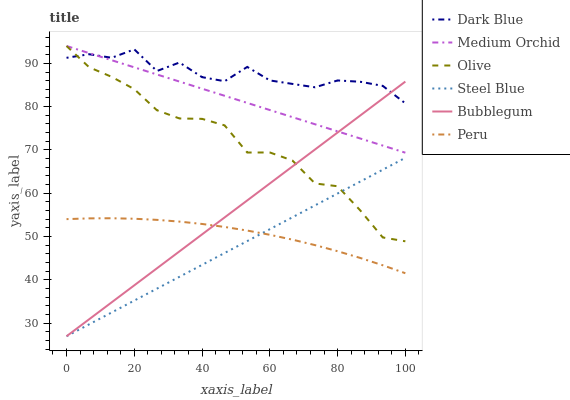Does Steel Blue have the minimum area under the curve?
Answer yes or no. Yes. Does Dark Blue have the maximum area under the curve?
Answer yes or no. Yes. Does Bubblegum have the minimum area under the curve?
Answer yes or no. No. Does Bubblegum have the maximum area under the curve?
Answer yes or no. No. Is Steel Blue the smoothest?
Answer yes or no. Yes. Is Dark Blue the roughest?
Answer yes or no. Yes. Is Bubblegum the smoothest?
Answer yes or no. No. Is Bubblegum the roughest?
Answer yes or no. No. Does Steel Blue have the lowest value?
Answer yes or no. Yes. Does Dark Blue have the lowest value?
Answer yes or no. No. Does Olive have the highest value?
Answer yes or no. Yes. Does Steel Blue have the highest value?
Answer yes or no. No. Is Steel Blue less than Medium Orchid?
Answer yes or no. Yes. Is Dark Blue greater than Peru?
Answer yes or no. Yes. Does Peru intersect Bubblegum?
Answer yes or no. Yes. Is Peru less than Bubblegum?
Answer yes or no. No. Is Peru greater than Bubblegum?
Answer yes or no. No. Does Steel Blue intersect Medium Orchid?
Answer yes or no. No. 